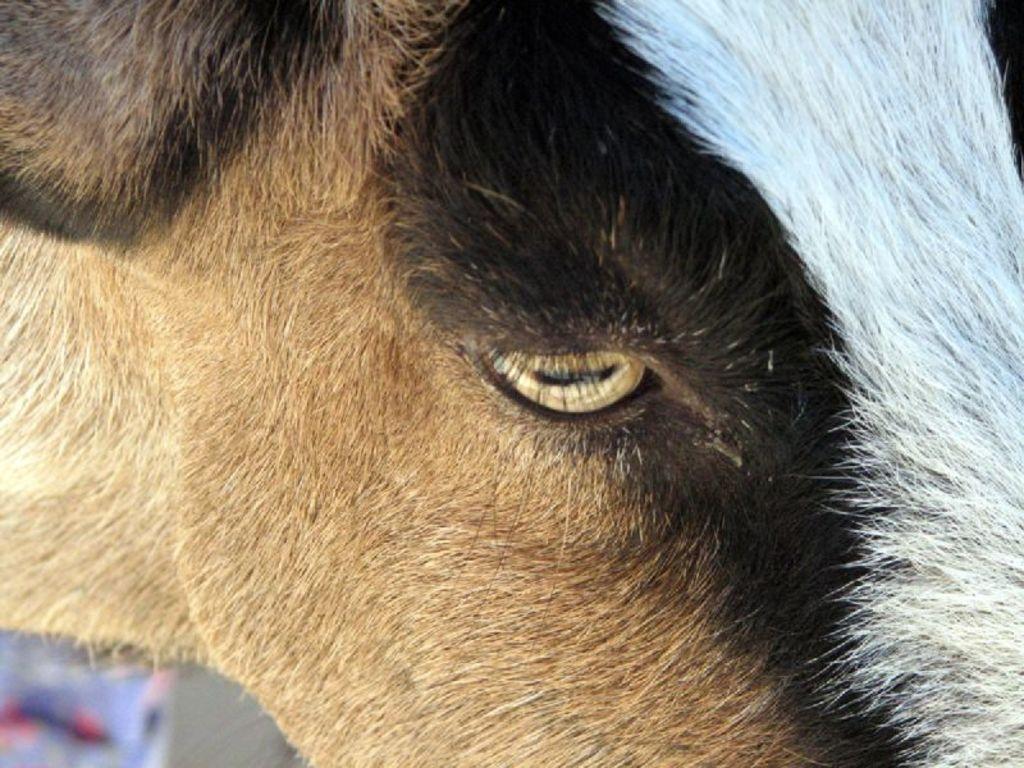In one or two sentences, can you explain what this image depicts? In the center of the image, there is an animal. 